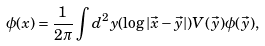<formula> <loc_0><loc_0><loc_500><loc_500>\phi ( x ) = \frac { 1 } { 2 \pi } \int d ^ { 2 } y ( \log | \vec { x } - \vec { y } | ) V ( \vec { y } ) \phi ( \vec { y } ) ,</formula> 